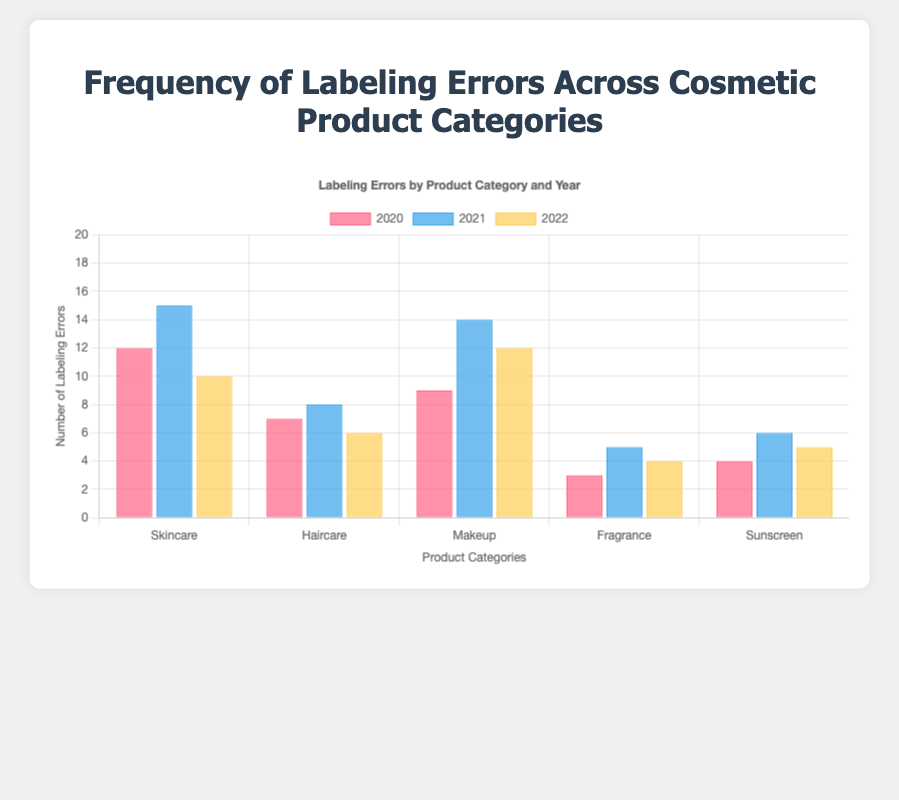Which product category had the highest number of labeling errors in 2021? To determine this, look at the bars for 2021. Among Skincare, Haircare, Makeup, Fragrance, and Sunscreen, the highest bar for 2021 corresponds to Skincare with 15 errors.
Answer: Skincare What is the total number of labeling errors for Makeup over the three years? Sum the errors for Makeup in 2020, 2021, and 2022: 9 + 14 + 12 = 35.
Answer: 35 Which category showed the greatest decrease in labeling errors from 2021 to 2022? Compute the difference for each category from 2021 to 2022: Skincare (15-10=5), Haircare (8-6=2), Makeup (14-12=2), Fragrance (5-4=1), Sunscreen (6-5=1). Skincare has the largest decrease.
Answer: Skincare Comparing Skincare and Haircare, which had more labeling errors in total across all years? Sum errors for each: Skincare (12+15+10=37), Haircare (7+8+6=21). Skincare has more total errors.
Answer: Skincare In which year did Sunscreen have the fewest labeling errors? Compare Sunscreen's errors in each year: 2020 (4), 2021 (6), 2022 (5). The fewest errors occurred in 2020.
Answer: 2020 What is the average number of labeling errors for Fragrance over the three years? Sum the errors for Fragrance and divide by the number of years: (3+5+4)/3 = 4.
Answer: 4 By how many errors did Makeup's labeling errors increase from 2020 to 2021? Subtract errors in 2020 from errors in 2021 for Makeup: 14 - 9 = 5.
Answer: 5 Which year had the lowest total number of labeling errors across all categories? Calculate the total errors for each year: 2020 (12+7+9+3+4=35), 2021 (15+8+14+5+6=48), 2022 (10+6+12+4+5=37). 2020 has the lowest total.
Answer: 2020 What is the median number of labeling errors for Haircare over the three years? Sort Haircare’s errors: [6, 7, 8]. The median value is the middle one, which is 7.
Answer: 7 Which category had consistent labeling errors (least variation) over the three years? Evaluate the range (difference between max and min values) for each category: Skincare (15-10=5), Haircare (8-6=2), Makeup (14-9=5), Fragrance (5-3=2), Sunscreen (6-4=2). Haircare, Fragrance, and Sunscreen all have a range of 2, indicating the least variation.
Answer: Haircare, Fragrance, Sunscreen 